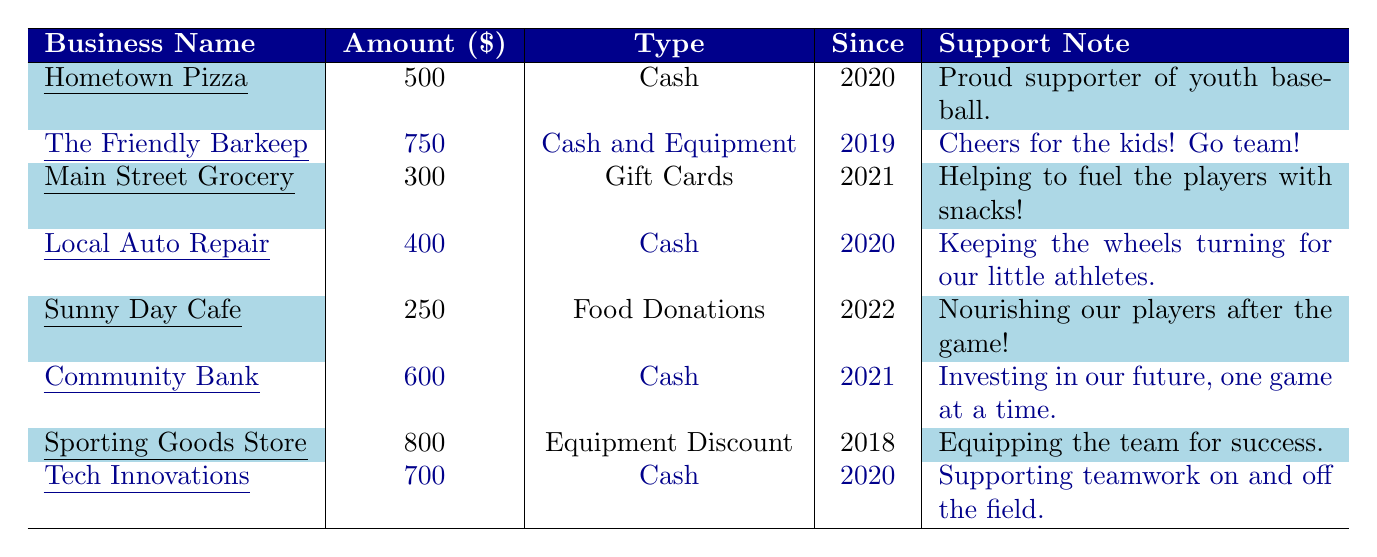What is the highest contribution amount from a business in the table? The table lists the contribution amounts for each business, and the maximum value seen is 800 from the Sporting Goods Store.
Answer: 800 Which business has been a sponsor since 2019? The Friendly Barkeep is the only business listed that has been a sponsor since 2019, as indicated in the column for Sponsor Since.
Answer: The Friendly Barkeep How many businesses have made cash contributions? By examining the Contribution Type column, there are 5 businesses (Hometown Pizza, The Friendly Barkeep, Local Auto Repair, Community Bank, Tech Innovations) that have made cash contributions.
Answer: 5 What is the total contribution amount from all businesses listed? Summing the contribution amounts: 500 + 750 + 300 + 400 + 250 + 600 + 800 + 700 gives a total of 4000.
Answer: 4000 Is there a business that contributes both cash and equipment? Yes, The Friendly Barkeep contributes both cash and equipment, as noted in the Contribution Type for that business.
Answer: Yes What is the average contribution amount of the businesses that started sponsoring since 2021? The businesses that started sponsoring in 2021 are Main Street Grocery and Community Bank, with contributions of 300 and 600, respectively. The average is (300 + 600)/2 = 450.
Answer: 450 Which business has the lowest contribution, and what is the amount? The Sunny Day Cafe has the lowest contribution of 250, as seen in the Contribution Amount column.
Answer: 250 How many businesses provide support notes focused on nourishing the team or players? Two businesses, Sunny Day Cafe (Nourishing our players after the game!) and Main Street Grocery (Helping to fuel the players with snacks!), have support notes related to nourishing the players.
Answer: 2 What can be inferred about the support provided by the Sporting Goods Store? The Sporting Goods Store has a significant contribution of 800 and a support note stating they are "Equipping the team for success," indicating a strong commitment to the team's needs.
Answer: They provide significant support focused on equipping the team What is the difference in contribution amounts between the top contributing business and the business that contributes food donations? The top contributing business is Sporting Goods Store with 800, and the business that provides food donations is Sunny Day Cafe with 250. The difference is 800 - 250 = 550.
Answer: 550 